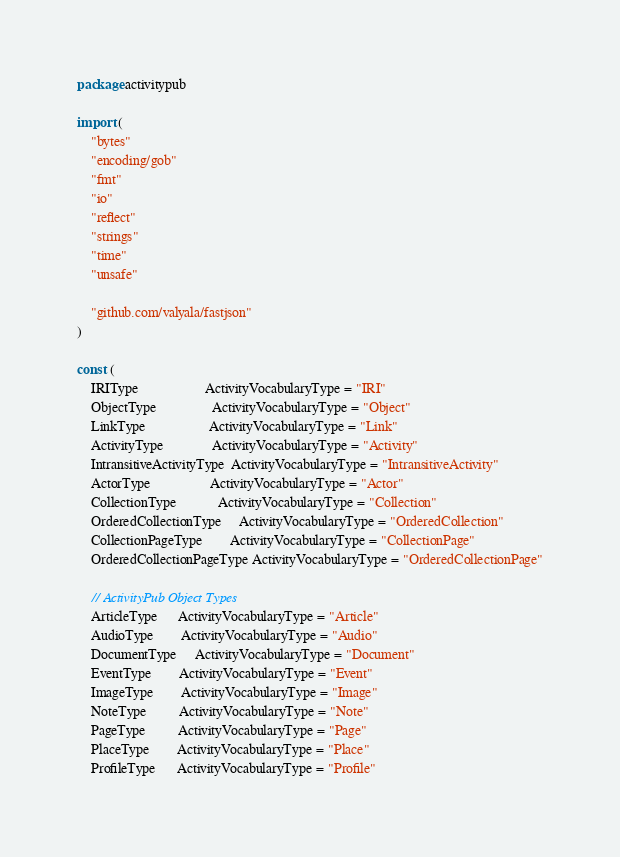Convert code to text. <code><loc_0><loc_0><loc_500><loc_500><_Go_>package activitypub

import (
	"bytes"
	"encoding/gob"
	"fmt"
	"io"
	"reflect"
	"strings"
	"time"
	"unsafe"

	"github.com/valyala/fastjson"
)

const (
	IRIType                   ActivityVocabularyType = "IRI"
	ObjectType                ActivityVocabularyType = "Object"
	LinkType                  ActivityVocabularyType = "Link"
	ActivityType              ActivityVocabularyType = "Activity"
	IntransitiveActivityType  ActivityVocabularyType = "IntransitiveActivity"
	ActorType                 ActivityVocabularyType = "Actor"
	CollectionType            ActivityVocabularyType = "Collection"
	OrderedCollectionType     ActivityVocabularyType = "OrderedCollection"
	CollectionPageType        ActivityVocabularyType = "CollectionPage"
	OrderedCollectionPageType ActivityVocabularyType = "OrderedCollectionPage"

	// ActivityPub Object Types
	ArticleType      ActivityVocabularyType = "Article"
	AudioType        ActivityVocabularyType = "Audio"
	DocumentType     ActivityVocabularyType = "Document"
	EventType        ActivityVocabularyType = "Event"
	ImageType        ActivityVocabularyType = "Image"
	NoteType         ActivityVocabularyType = "Note"
	PageType         ActivityVocabularyType = "Page"
	PlaceType        ActivityVocabularyType = "Place"
	ProfileType      ActivityVocabularyType = "Profile"</code> 